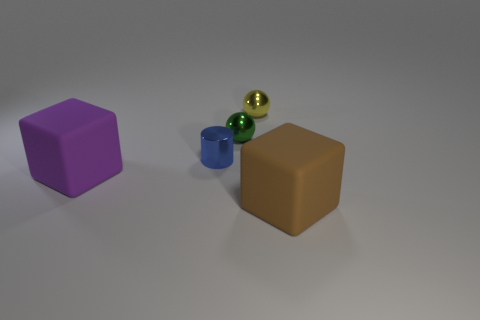What color is the metallic cylinder that is the same size as the green thing?
Provide a short and direct response. Blue. What number of other things are there of the same shape as the tiny blue thing?
Give a very brief answer. 0. There is a metallic object on the left side of the green ball; how big is it?
Provide a short and direct response. Small. There is a block that is on the right side of the shiny cylinder; how many large brown rubber things are to the right of it?
Keep it short and to the point. 0. What number of other things are the same size as the brown cube?
Keep it short and to the point. 1. Do the rubber object that is left of the tiny green shiny object and the green metal thing have the same shape?
Offer a terse response. No. What number of objects are in front of the green sphere and right of the purple block?
Provide a short and direct response. 2. What material is the blue object?
Give a very brief answer. Metal. Is there any other thing that has the same color as the metallic cylinder?
Ensure brevity in your answer.  No. Are the blue cylinder and the yellow sphere made of the same material?
Provide a short and direct response. Yes. 